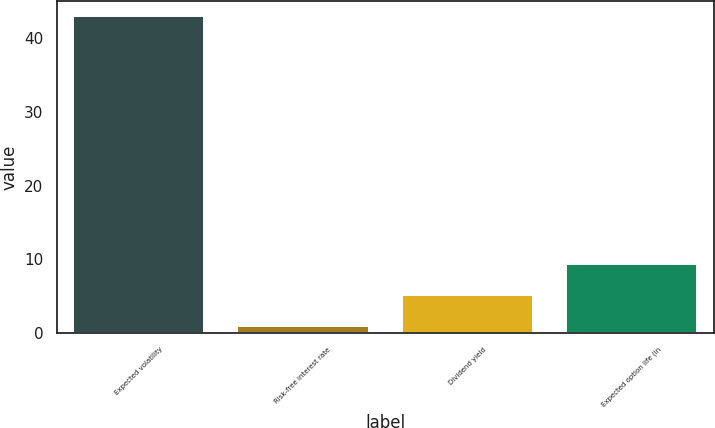Convert chart to OTSL. <chart><loc_0><loc_0><loc_500><loc_500><bar_chart><fcel>Expected volatility<fcel>Risk-free interest rate<fcel>Dividend yield<fcel>Expected option life (in<nl><fcel>42.93<fcel>0.98<fcel>5.18<fcel>9.38<nl></chart> 